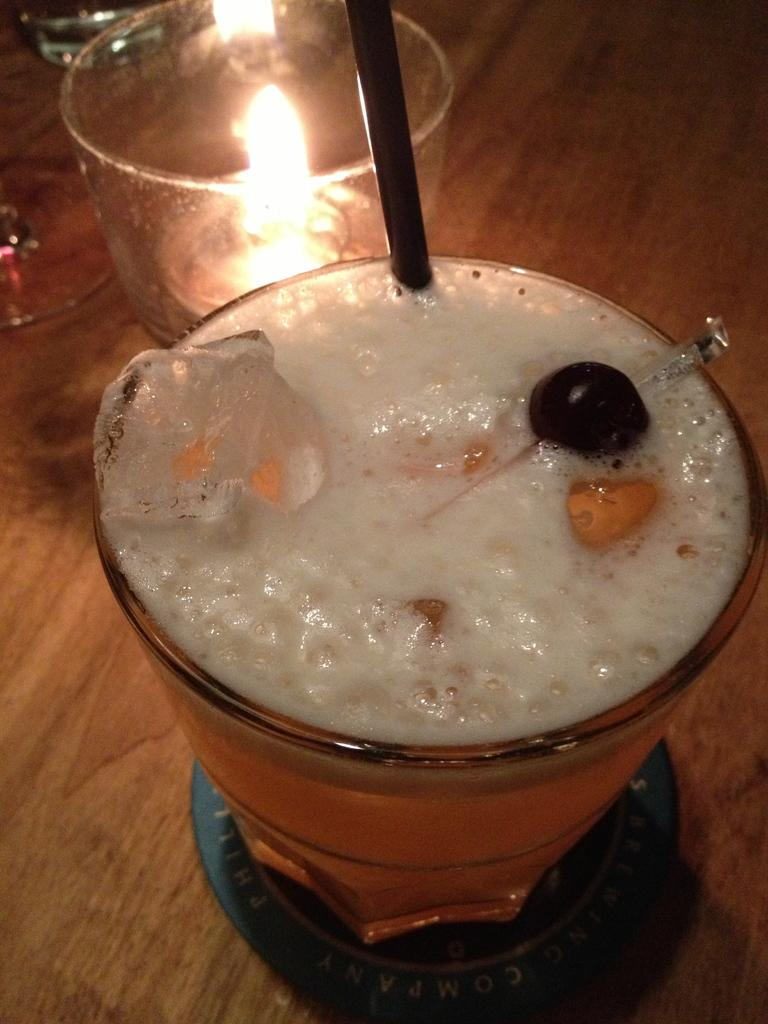What is the main object in the center of the image? There is a glass in the center of the image. What is inside the glass? The glass contains liquid substances. How can someone drink the liquid in the glass? There is a straw in the glass. What other objects related to the glass can be seen in the image? There is a candle and other glasses in the image. How does the sun affect the snow in the image? There is no sun or snow present in the image; it only features a glass, a straw, a candle, and other glasses. 